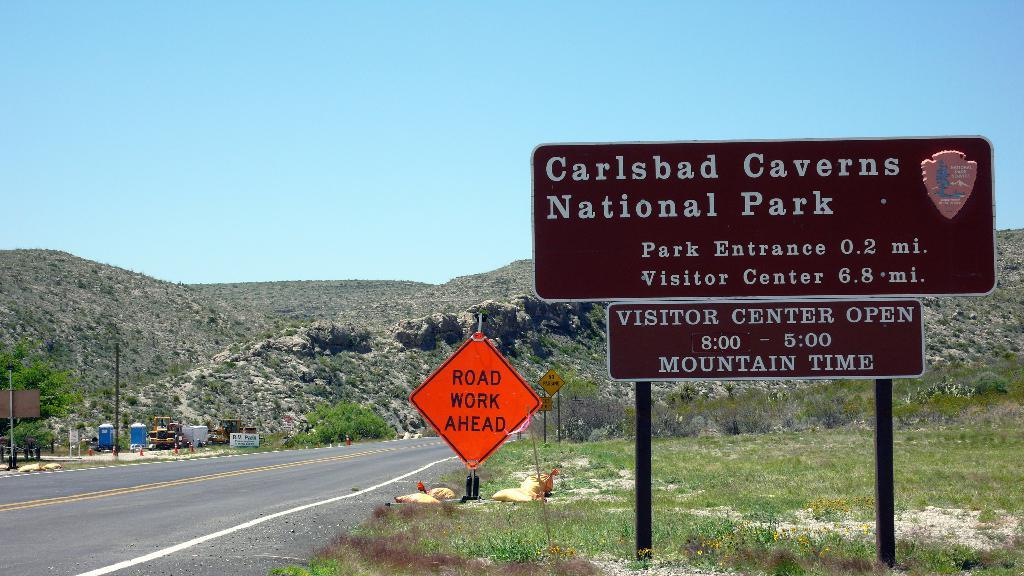<image>
Offer a succinct explanation of the picture presented. A road leads to the entrance of Carlsbad Caverns National Park. 